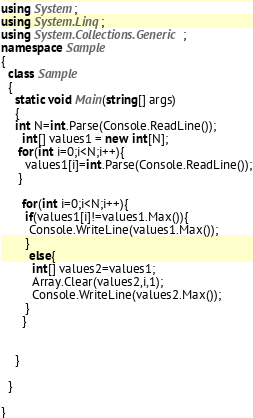Convert code to text. <code><loc_0><loc_0><loc_500><loc_500><_C#_>using System;
using System.Linq;
using System.Collections.Generic;
namespace Sample
{
  class Sample
  {
    static void Main(string[] args)
    {
    int N=int.Parse(Console.ReadLine());
      int[] values1 = new int[N];
     for(int i=0;i<N;i++){
       values1[i]=int.Parse(Console.ReadLine());
     }
     
      for(int i=0;i<N;i++){
       if(values1[i]!=values1.Max()){
        Console.WriteLine(values1.Max()); 
       }
        else{
         int[] values2=values1;
         Array.Clear(values2,i,1);
         Console.WriteLine(values2.Max());
       }
      }
      
      
    }
    
  }

}
</code> 